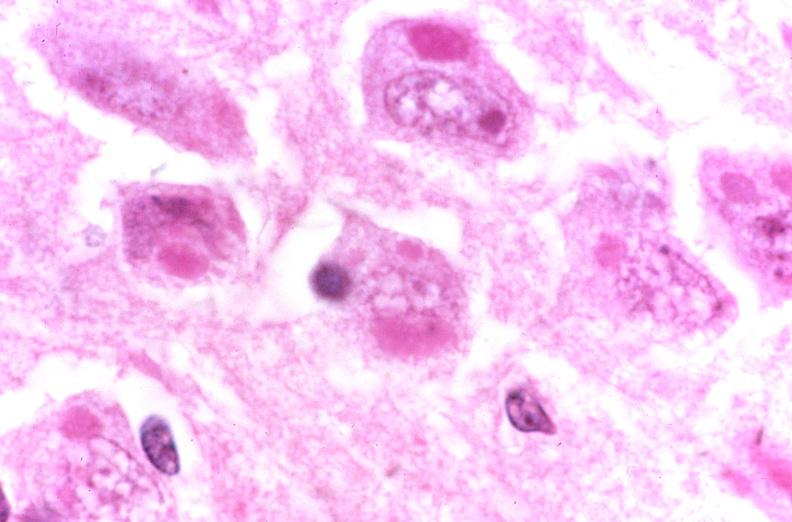does this image show brain, rabies, inclusion dodies negri bodies?
Answer the question using a single word or phrase. Yes 